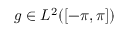<formula> <loc_0><loc_0><loc_500><loc_500>g \in L ^ { 2 } ( [ - \pi , \pi ] )</formula> 